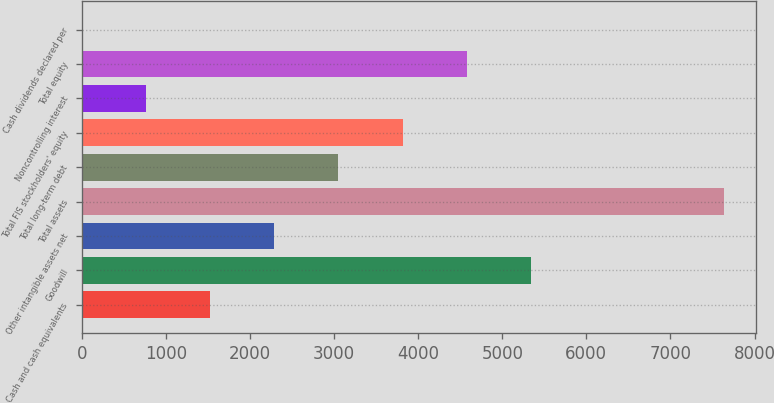Convert chart. <chart><loc_0><loc_0><loc_500><loc_500><bar_chart><fcel>Cash and cash equivalents<fcel>Goodwill<fcel>Other intangible assets net<fcel>Total assets<fcel>Total long-term debt<fcel>Total FIS stockholders' equity<fcel>Noncontrolling interest<fcel>Total equity<fcel>Cash dividends declared per<nl><fcel>1526.28<fcel>5341.48<fcel>2289.32<fcel>7630.6<fcel>3052.36<fcel>3815.4<fcel>763.24<fcel>4578.44<fcel>0.2<nl></chart> 